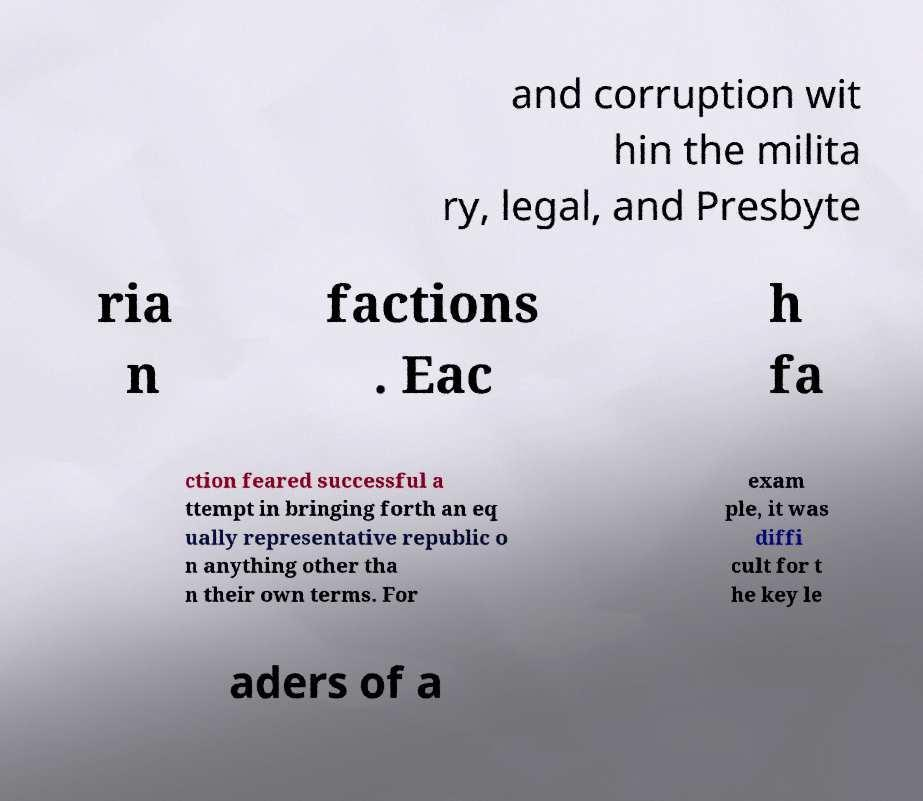Can you accurately transcribe the text from the provided image for me? and corruption wit hin the milita ry, legal, and Presbyte ria n factions . Eac h fa ction feared successful a ttempt in bringing forth an eq ually representative republic o n anything other tha n their own terms. For exam ple, it was diffi cult for t he key le aders of a 